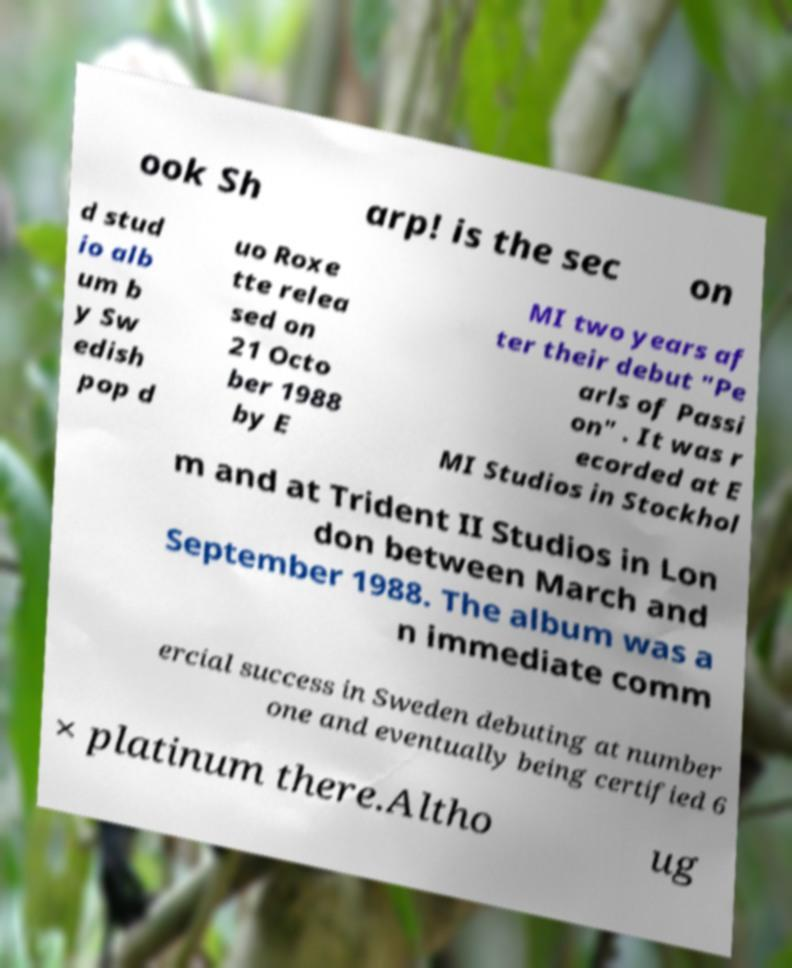What messages or text are displayed in this image? I need them in a readable, typed format. ook Sh arp! is the sec on d stud io alb um b y Sw edish pop d uo Roxe tte relea sed on 21 Octo ber 1988 by E MI two years af ter their debut "Pe arls of Passi on" . It was r ecorded at E MI Studios in Stockhol m and at Trident II Studios in Lon don between March and September 1988. The album was a n immediate comm ercial success in Sweden debuting at number one and eventually being certified 6 × platinum there.Altho ug 